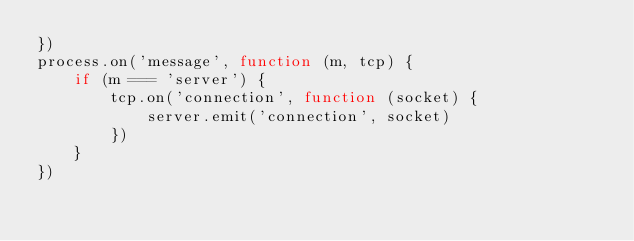Convert code to text. <code><loc_0><loc_0><loc_500><loc_500><_JavaScript_>})
process.on('message', function (m, tcp) {
    if (m === 'server') {
        tcp.on('connection', function (socket) {
            server.emit('connection', socket)
        })
    }
})
</code> 